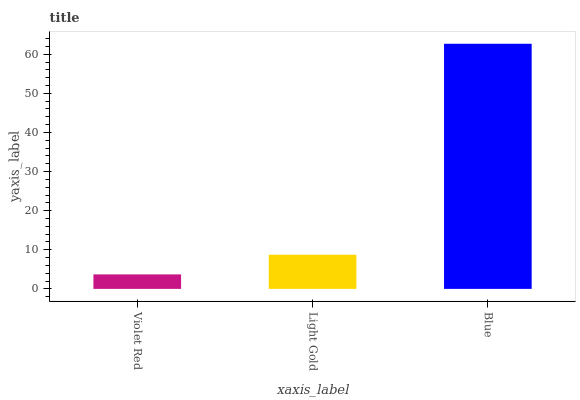Is Violet Red the minimum?
Answer yes or no. Yes. Is Blue the maximum?
Answer yes or no. Yes. Is Light Gold the minimum?
Answer yes or no. No. Is Light Gold the maximum?
Answer yes or no. No. Is Light Gold greater than Violet Red?
Answer yes or no. Yes. Is Violet Red less than Light Gold?
Answer yes or no. Yes. Is Violet Red greater than Light Gold?
Answer yes or no. No. Is Light Gold less than Violet Red?
Answer yes or no. No. Is Light Gold the high median?
Answer yes or no. Yes. Is Light Gold the low median?
Answer yes or no. Yes. Is Blue the high median?
Answer yes or no. No. Is Violet Red the low median?
Answer yes or no. No. 